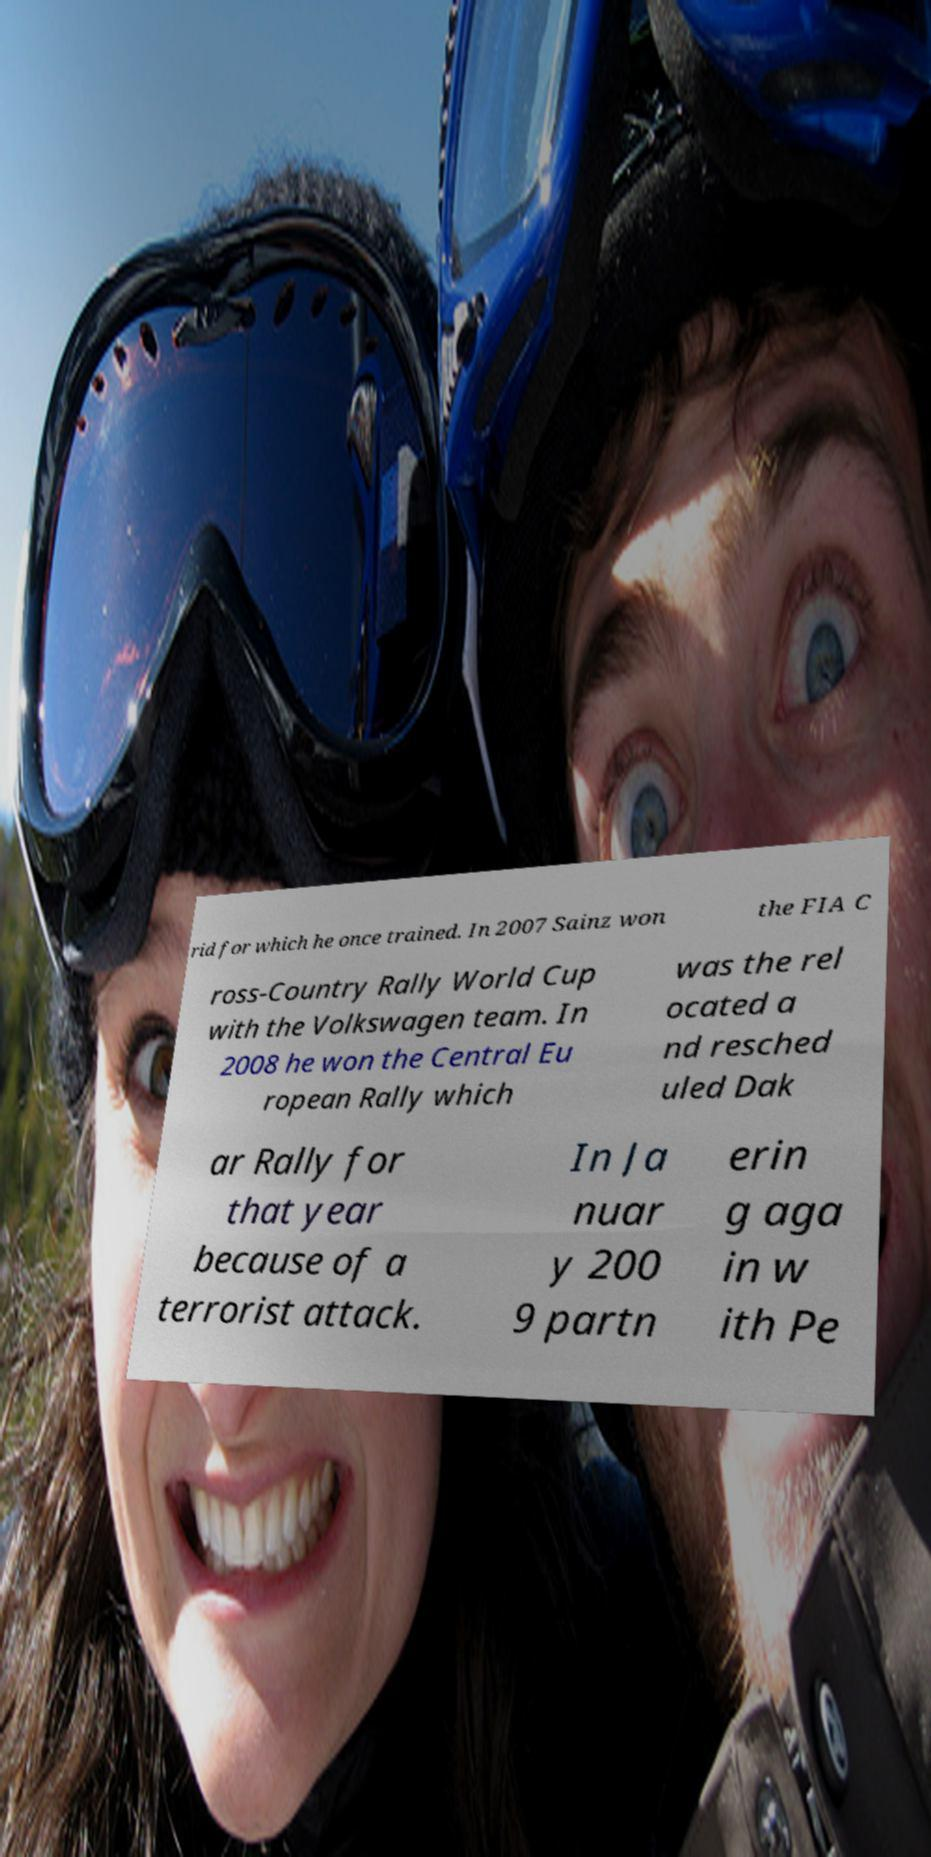Can you accurately transcribe the text from the provided image for me? rid for which he once trained. In 2007 Sainz won the FIA C ross-Country Rally World Cup with the Volkswagen team. In 2008 he won the Central Eu ropean Rally which was the rel ocated a nd resched uled Dak ar Rally for that year because of a terrorist attack. In Ja nuar y 200 9 partn erin g aga in w ith Pe 